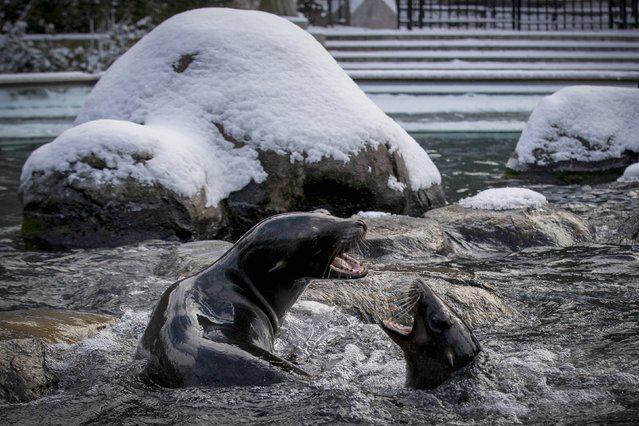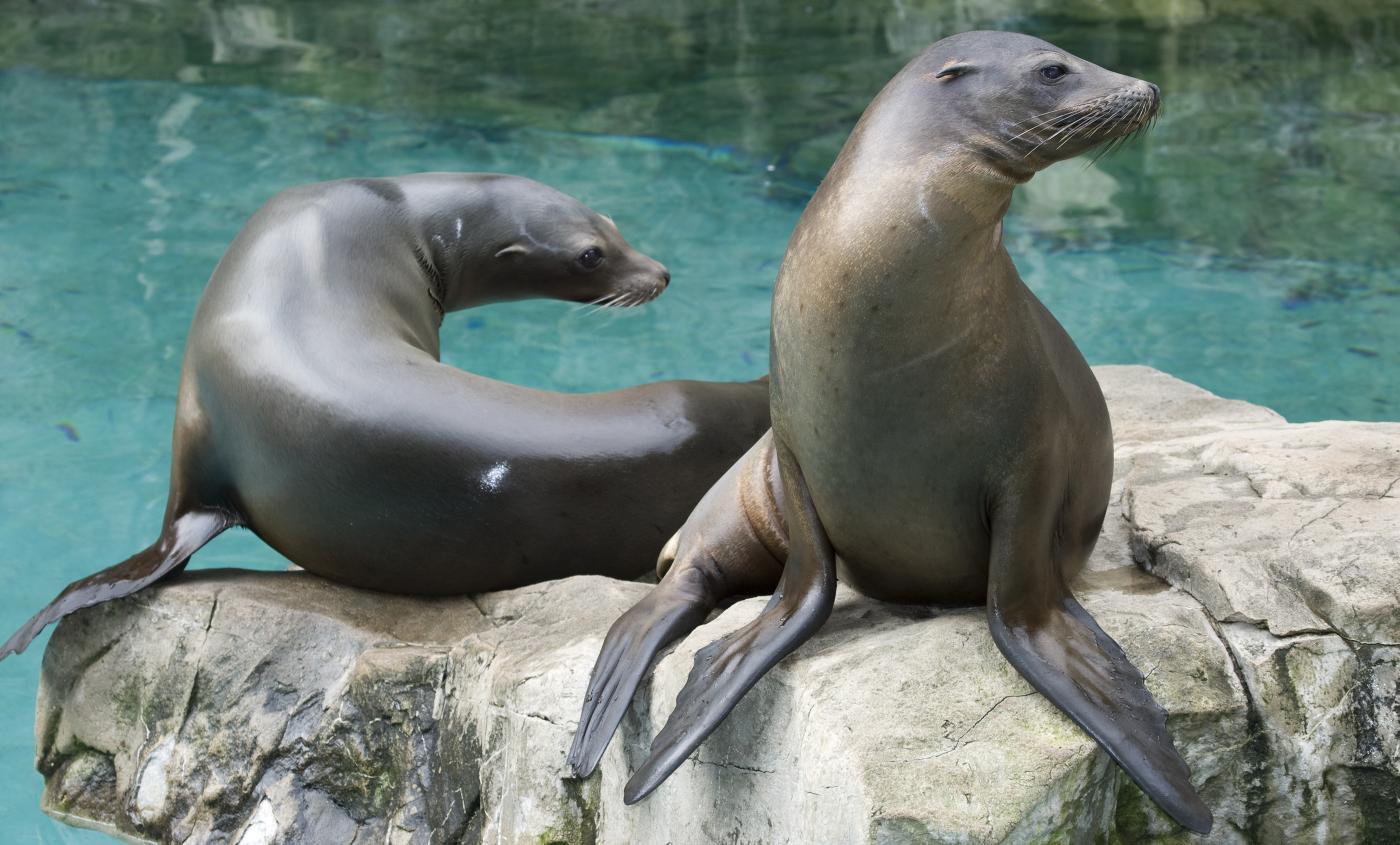The first image is the image on the left, the second image is the image on the right. Given the left and right images, does the statement "There are no more than three seals sunning in one of the images." hold true? Answer yes or no. Yes. 